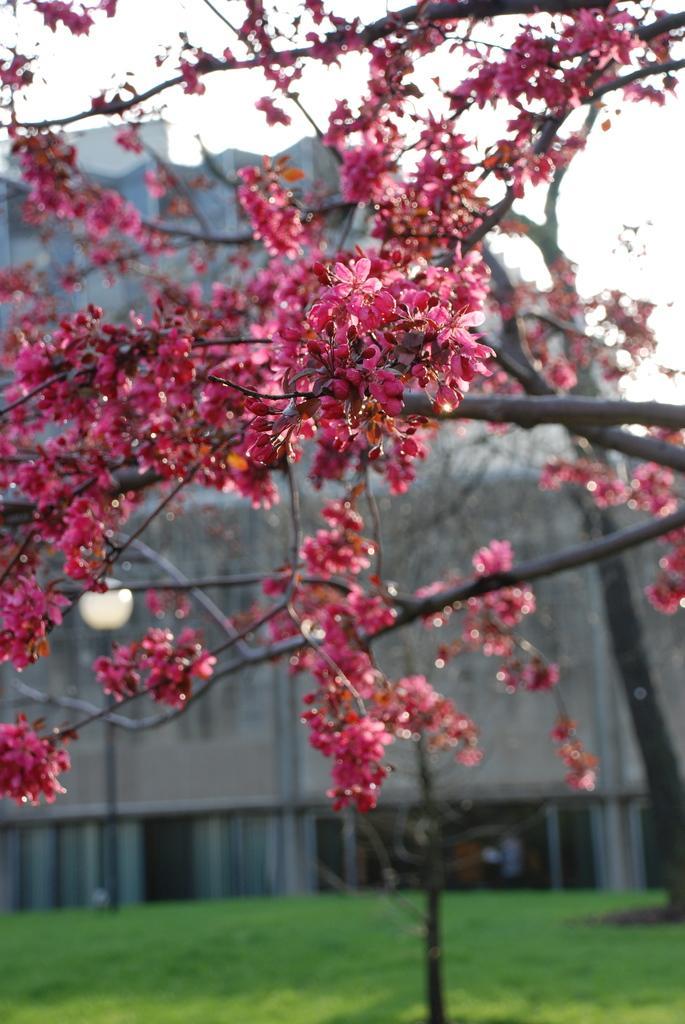Please provide a concise description of this image. In this image there is a tree with red flowers, behind that there is a building and grass in front of that. 